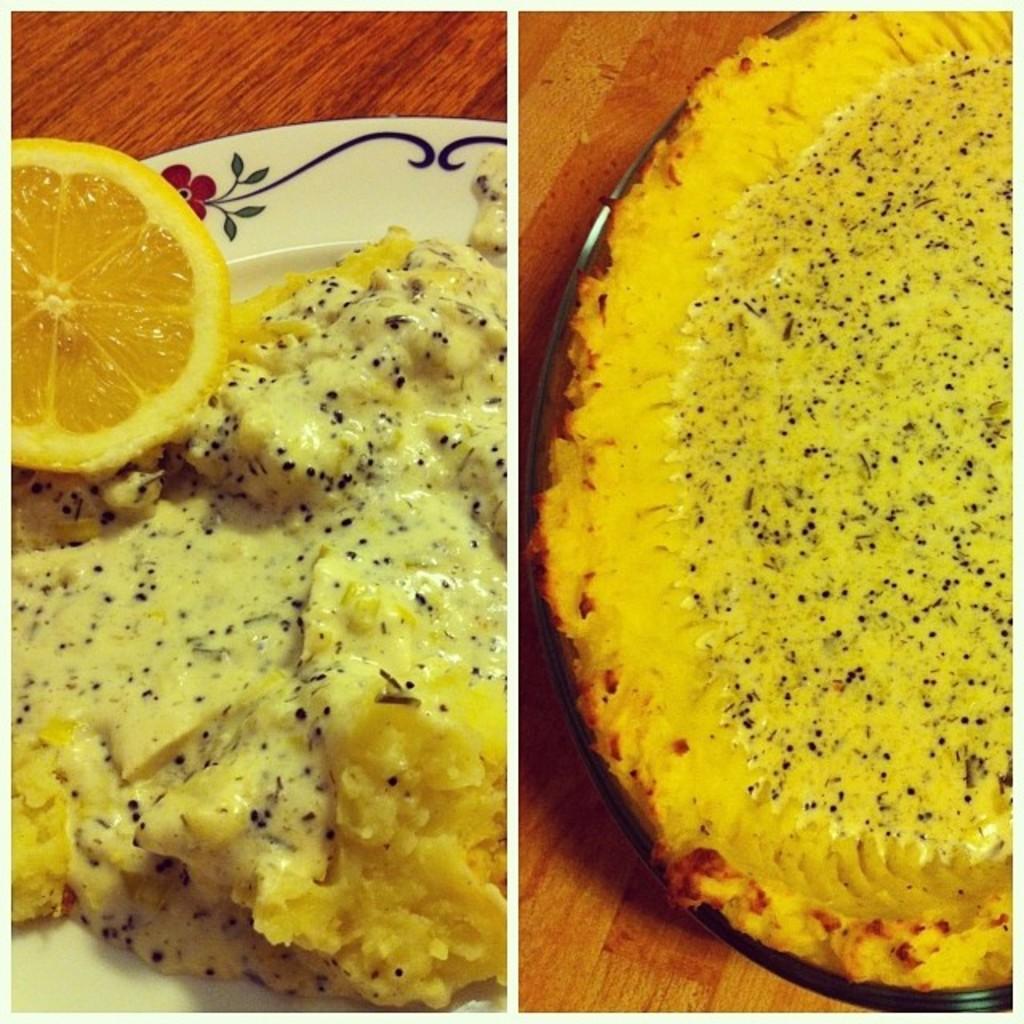Could you give a brief overview of what you see in this image? This is an image with collage in which we can see some food and a piece of lemon in a plate which is placed on the wooden surface. 